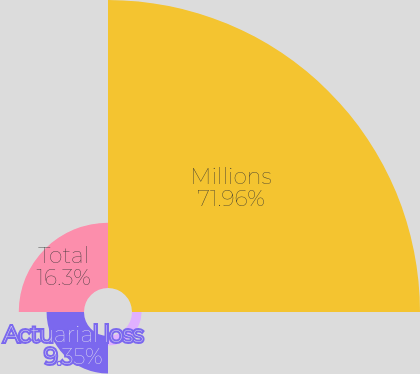<chart> <loc_0><loc_0><loc_500><loc_500><pie_chart><fcel>Millions<fcel>Net actuarial (loss)/gain<fcel>Actuarial loss<fcel>Total<nl><fcel>71.96%<fcel>2.39%<fcel>9.35%<fcel>16.3%<nl></chart> 